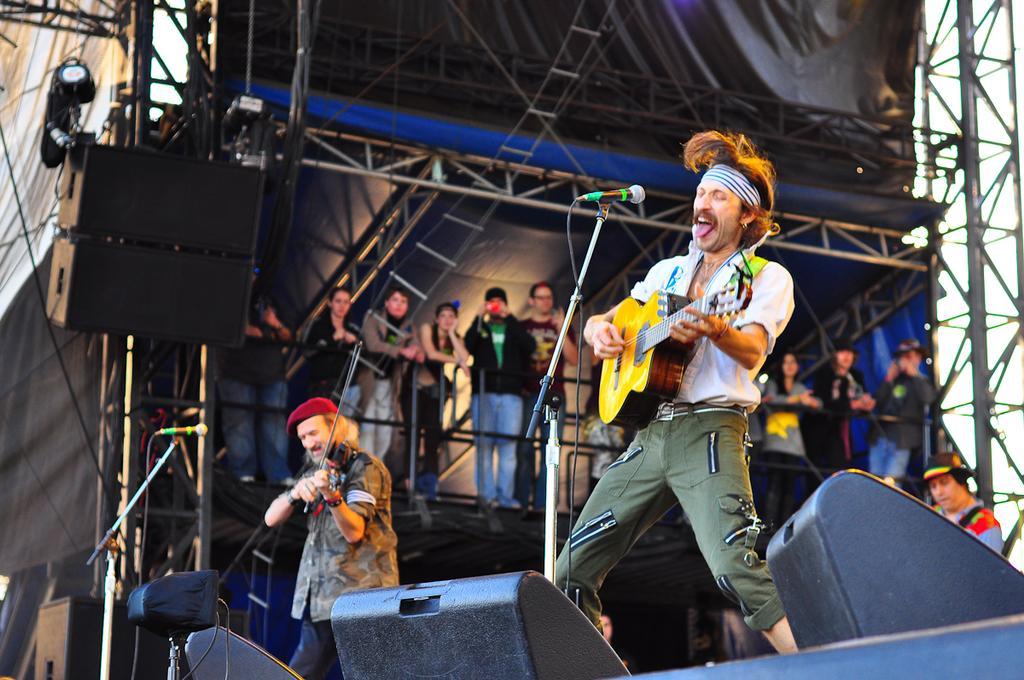Please provide a concise description of this image. In this image I can see two people are standing on the stage and playing musical instruments. On the stage there are mics and sound boxes. In the back ground there are group of people standing and seeing them. And these people are under the tent. 